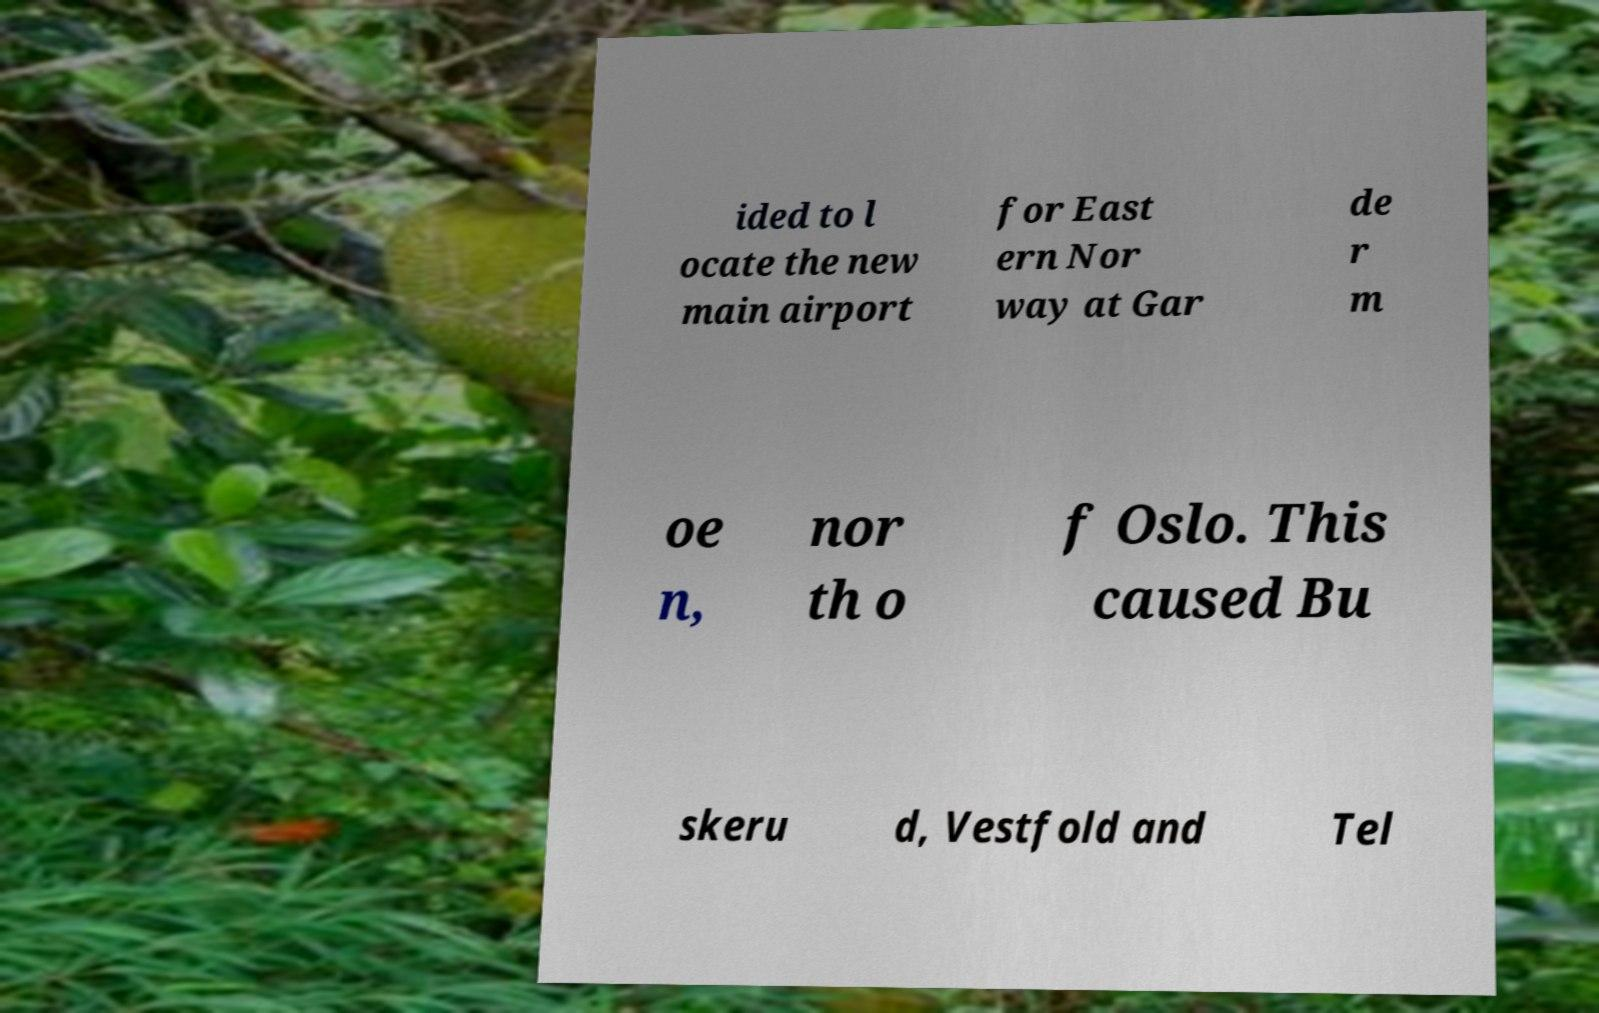What messages or text are displayed in this image? I need them in a readable, typed format. ided to l ocate the new main airport for East ern Nor way at Gar de r m oe n, nor th o f Oslo. This caused Bu skeru d, Vestfold and Tel 